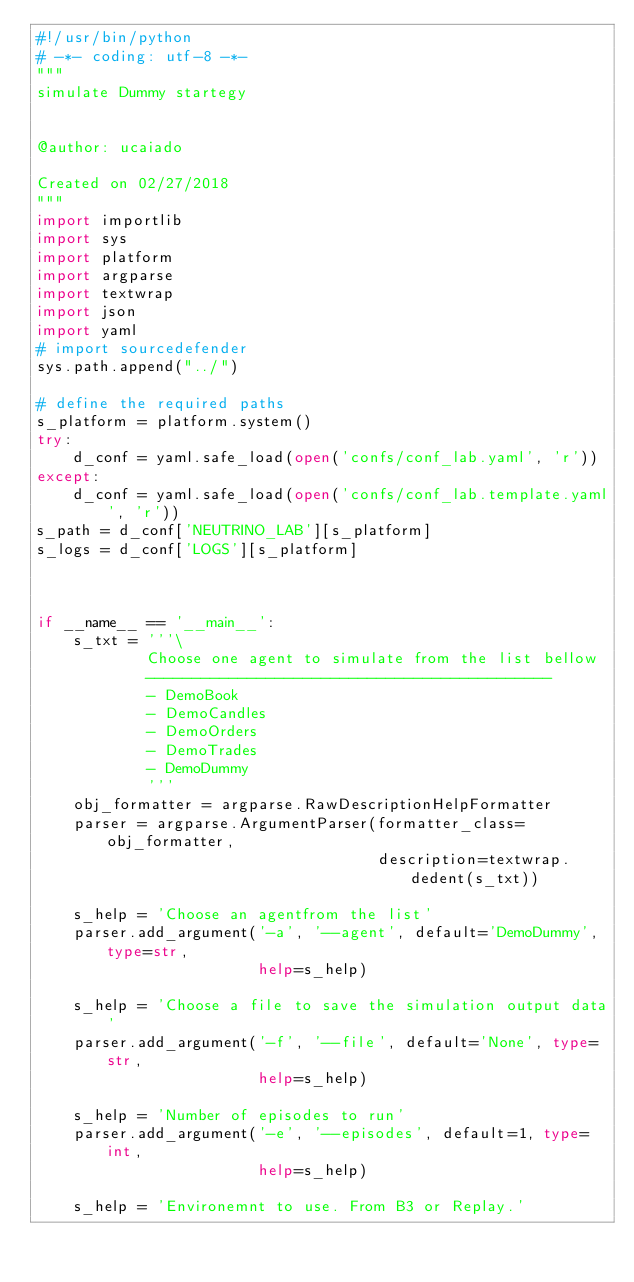<code> <loc_0><loc_0><loc_500><loc_500><_Python_>#!/usr/bin/python
# -*- coding: utf-8 -*-
"""
simulate Dummy startegy


@author: ucaiado

Created on 02/27/2018
"""
import importlib
import sys
import platform
import argparse
import textwrap
import json
import yaml
# import sourcedefender
sys.path.append("../")

# define the required paths
s_platform = platform.system()
try:
    d_conf = yaml.safe_load(open('confs/conf_lab.yaml', 'r'))
except:
    d_conf = yaml.safe_load(open('confs/conf_lab.template.yaml', 'r'))
s_path = d_conf['NEUTRINO_LAB'][s_platform]
s_logs = d_conf['LOGS'][s_platform]



if __name__ == '__main__':
    s_txt = '''\
            Choose one agent to simulate from the list bellow
            --------------------------------------------
            - DemoBook
            - DemoCandles
            - DemoOrders
            - DemoTrades
            - DemoDummy
            '''
    obj_formatter = argparse.RawDescriptionHelpFormatter
    parser = argparse.ArgumentParser(formatter_class=obj_formatter,
                                     description=textwrap.dedent(s_txt))

    s_help = 'Choose an agentfrom the list'
    parser.add_argument('-a', '--agent', default='DemoDummy', type=str,
                        help=s_help)

    s_help = 'Choose a file to save the simulation output data'
    parser.add_argument('-f', '--file', default='None', type=str,
                        help=s_help)

    s_help = 'Number of episodes to run'
    parser.add_argument('-e', '--episodes', default=1, type=int,
                        help=s_help)

    s_help = 'Environemnt to use. From B3 or Replay.'</code> 